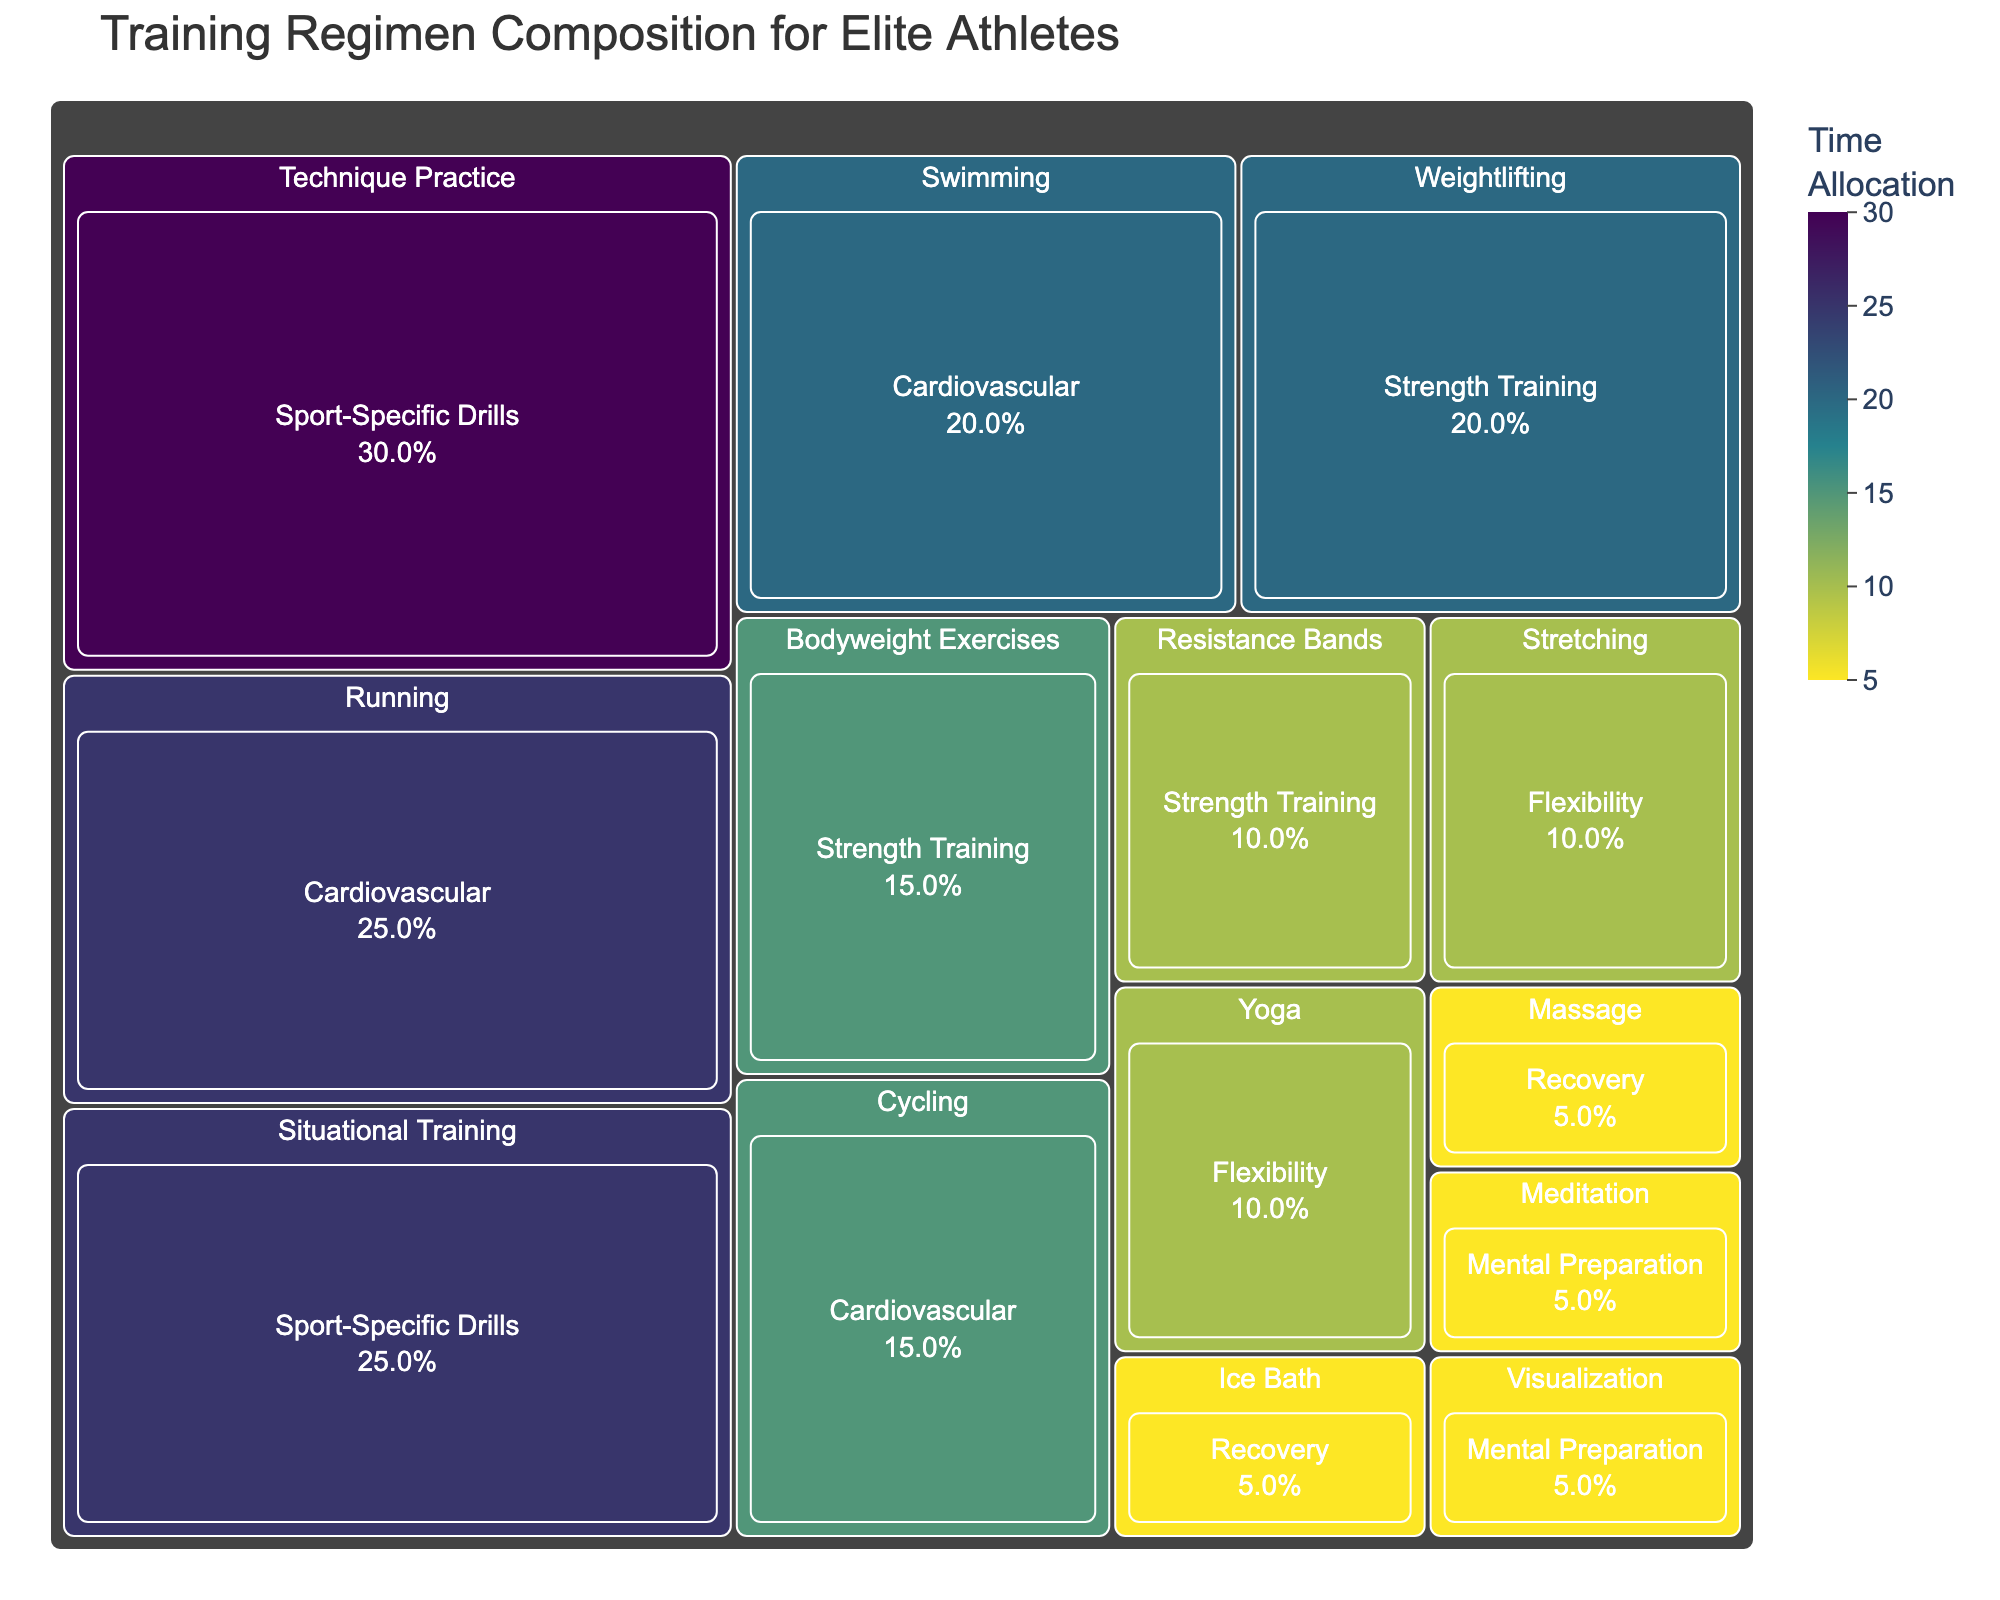What is the title of the treemap? The title is usually located at the top of the figure and provides an overview of what the visual represents. In this case, it describes the composition of training regimens for elite athletes.
Answer: Training Regimen Composition for Elite Athletes Which exercise category has the highest time allocation? Examine the different categories and their corresponding time allocations. By comparing the values, you can identify which category has the highest time allocation.
Answer: Sport-Specific Drills What is the total time allocation for Cardiovascular exercises? Add up the time allocations of Running, Swimming, and Cycling. The total gives a composite view of the Cardiovascular category.
Answer: 60 How does the time allocation for Yoga compare to that for Stretching? Look at the time allocated to each exercise in the Flexibility category and compare them directly.
Answer: They are equal What percentage of total training time is spent on Recovery exercises? Add the time allocations for Massage and Ice Bath to get the total for Recovery. Then, sum up all categories' total allocations to find the percentage. (5+5)/(total 200) * 100
Answer: 5% Which category has more diverse types of exercises, Strength Training or Cardiovascular? Compare the number of exercise types listed under each category. Strength Training has three while Cardiovascular has three, so they are equally diverse.
Answer: They are equally diverse How much more time is allocated to Running than Cycling? Subtract the time allocation of Cycling from that of Running.
Answer: 10 What is the largest individual time allocation for an exercise, and which exercise is it? Find the highest individual value in the time allocation column and identify the corresponding exercise.
Answer: Technique Practice, 30 